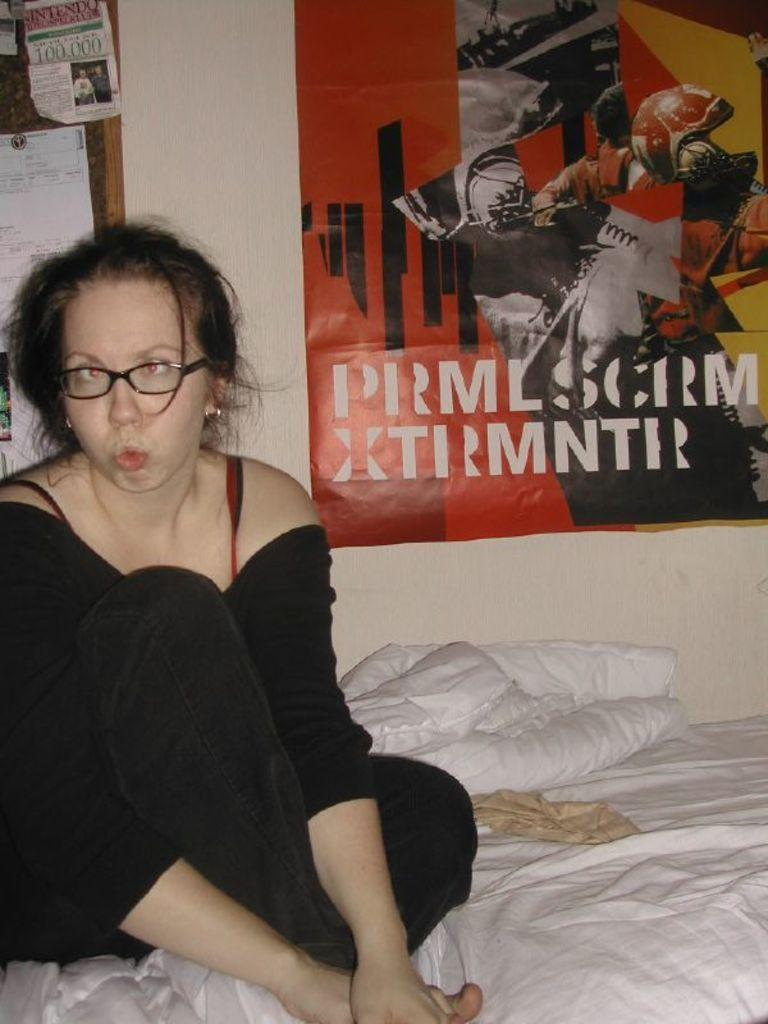Who is present in the image? There is a woman in the image. What is the woman wearing in the image? The woman is wearing spectacles in the image. What can be seen on the woman's body in the image? Clothes are visible in the image. What is visible in the background of the image? There is a wall and posters in the background of the image. What is the woman's opinion on the topic of birthday celebrations in the image? There is no information about the woman's opinion on birthday celebrations in the image. Can you tell me how the woman blows out the candles on her birthday cake in the image? There is no birthday cake or candles present in the image. 